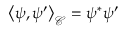<formula> <loc_0><loc_0><loc_500><loc_500>\left \langle \psi , \psi ^ { \prime } \right \rangle _ { \mathcal { C } } = \psi ^ { * } \psi ^ { \prime }</formula> 